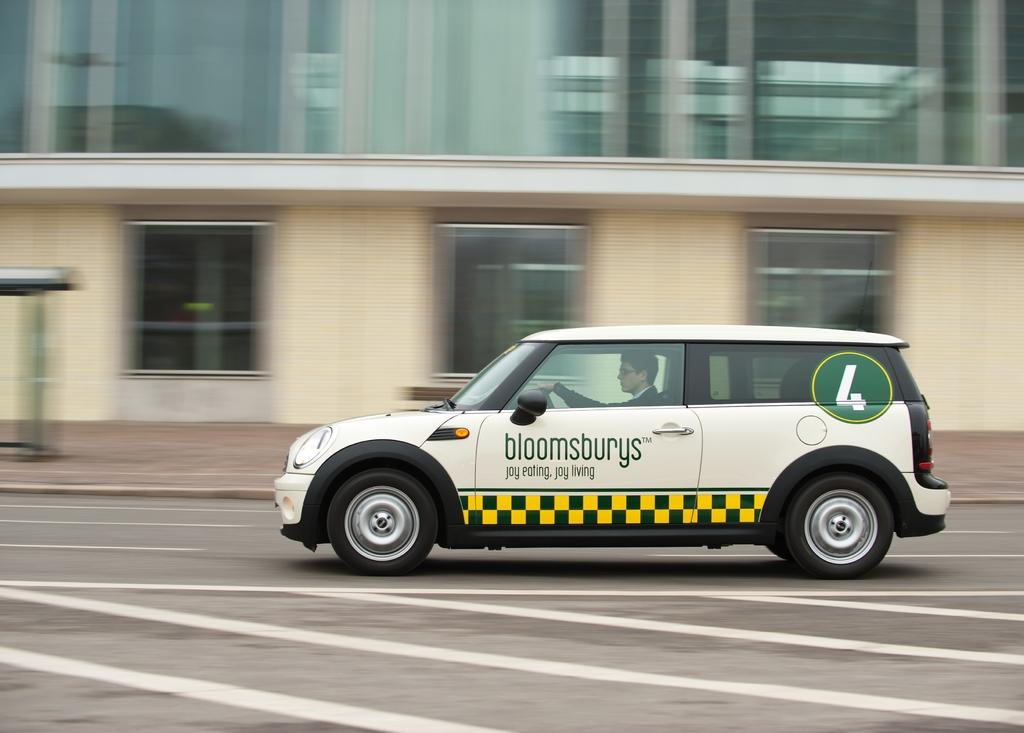What is the person in the image doing? The person is riding a car. What color is the car they are riding? The car is white in color. Where is the car located? The car is on the road. What can be seen near the car? There is a building beside the car. What type of invention is being demonstrated by the crowd in the image? There is no crowd present in the image, and no invention is being demonstrated. 